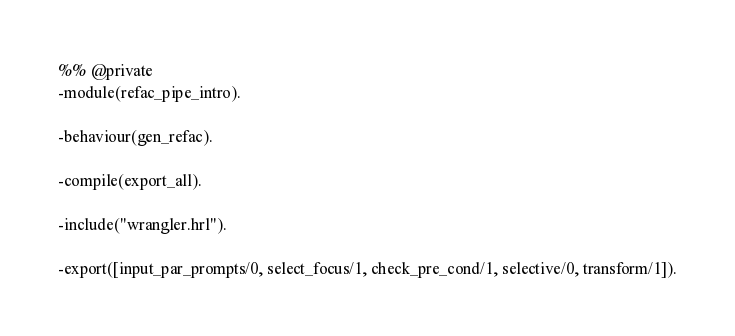<code> <loc_0><loc_0><loc_500><loc_500><_Erlang_>%% @private
-module(refac_pipe_intro).

-behaviour(gen_refac).

-compile(export_all).

-include("wrangler.hrl").

-export([input_par_prompts/0, select_focus/1, check_pre_cond/1, selective/0, transform/1]).
</code> 